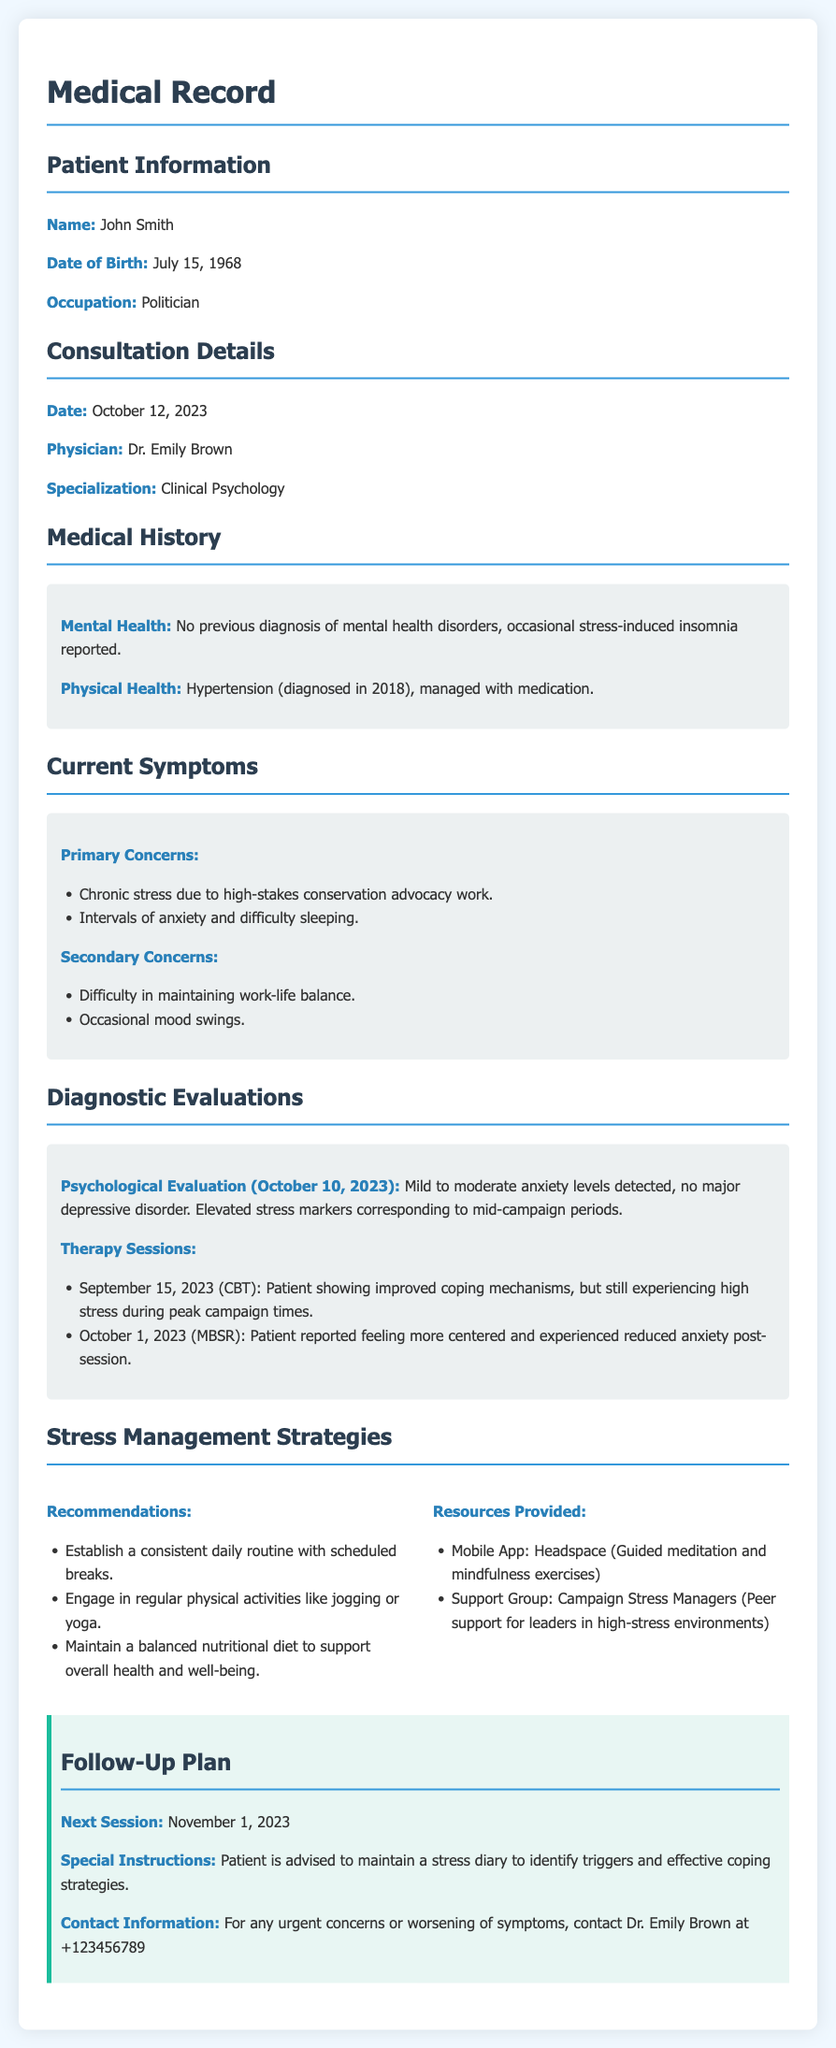What is the name of the patient? The patient's name is listed in the Patient Information section.
Answer: John Smith What is the date of the consultation? The consultation date is mentioned under the Consultation Details section.
Answer: October 12, 2023 Who is the physician? The physician's name is specified in the Consultation Details section.
Answer: Dr. Emily Brown What were the primary concerns during the current evaluation? The primary concerns are listed in the Current Symptoms section.
Answer: Chronic stress due to high-stakes conservation advocacy work; Intervals of anxiety and difficulty sleeping What was the date of the psychological evaluation? The date of the psychological evaluation is provided in the Diagnostic Evaluations section.
Answer: October 10, 2023 What therapy session type was conducted on September 15, 2023? The type of therapy session is indicated in the Diagnostic Evaluations section.
Answer: CBT How often is the patient advised to maintain a stress diary? The advice regarding maintaining a stress diary can be found in the Follow-Up Plan section.
Answer: Advises to maintain continuously Which mobile app was provided as a resource? The mobile app is listed under the Stress Management Strategies section.
Answer: Headspace What is the occupation of the patient? The occupation is mentioned in the Patient Information section.
Answer: Politician 